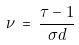Convert formula to latex. <formula><loc_0><loc_0><loc_500><loc_500>\nu \, = \, \frac { \tau - 1 } { { \sigma } d }</formula> 